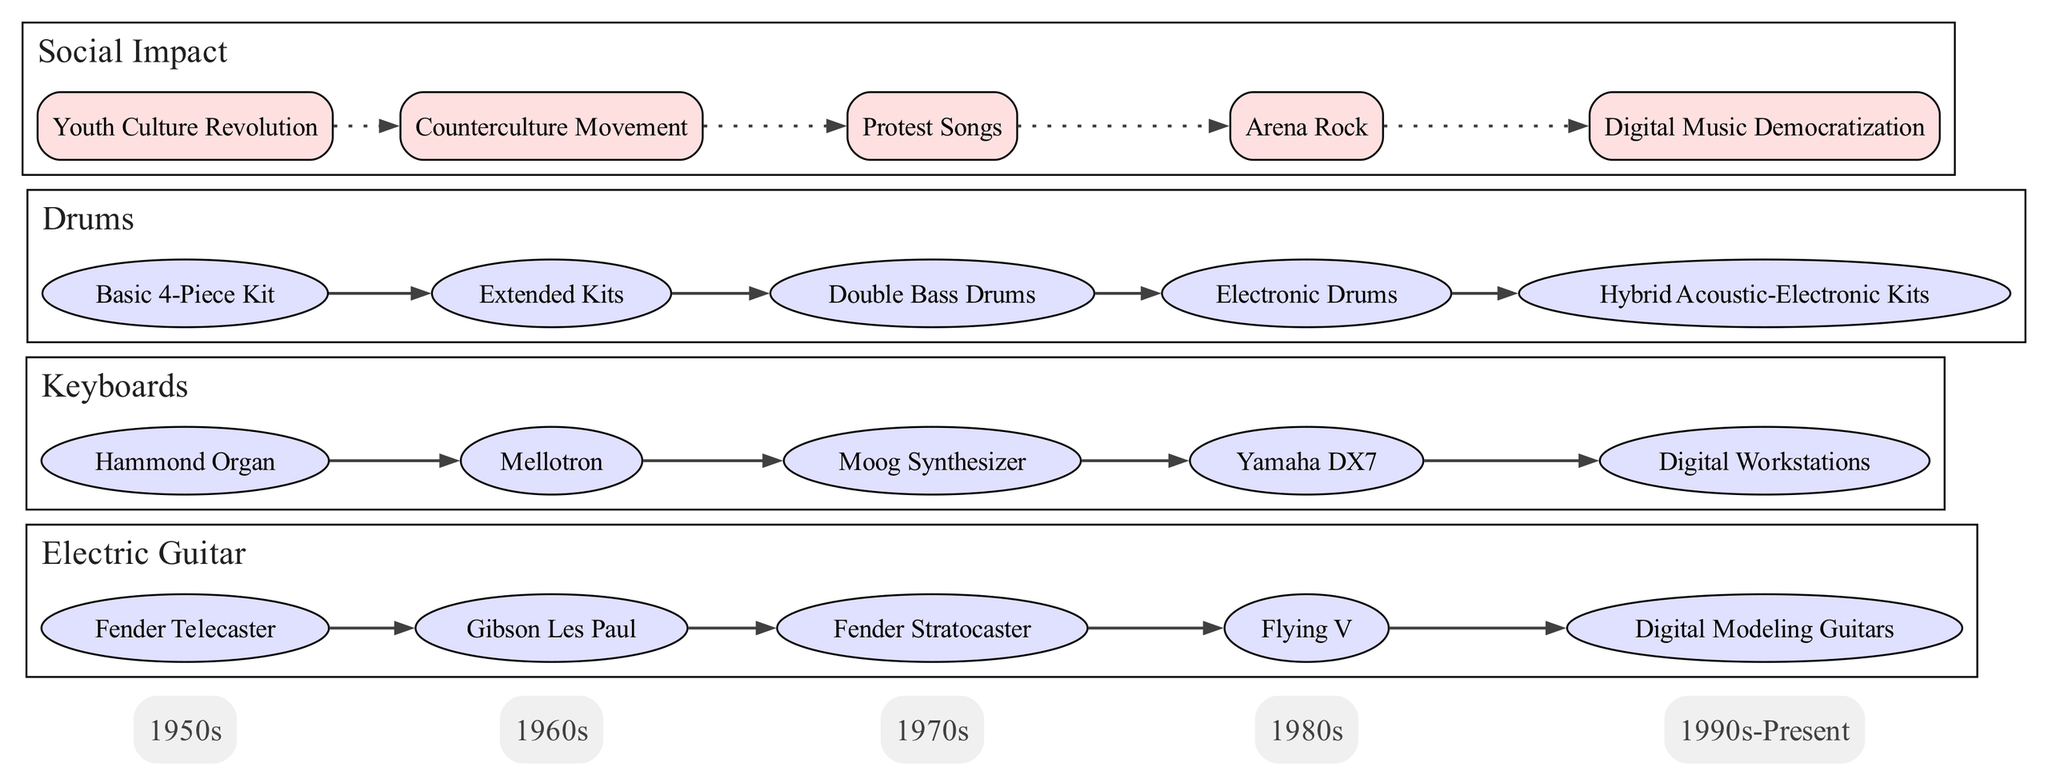What instrument evolved into the Moog Synthesizer? From the diagram, the evolution of Keyboards includes Hammond Organ leading to Mellotron, then to Moog Synthesizer. Therefore, the immediate predecessor to the Moog Synthesizer is the Mellotron.
Answer: Mellotron How many instruments are shown in the diagram? The diagram features three main instruments: Electric Guitar, Keyboards, and Drums. Counting these gives a total of three instruments displayed.
Answer: Three What instrument type was developed in the 1980s? The diagram lists specific instruments under key decades. For the 1980s, the Digital Modeling Guitars for Electric Guitars, Yamaha DX7 for Keyboards, and Electronic Drums for Drums are present. Therefore, Digital Modeling Guitars is an example of an instrument developed in the 1980s.
Answer: Digital Modeling Guitars Which decade introduced Extended Kits for Drums? By examining the timeline and the specific evolution listed for Drums, Extended Kits are indicated as an evolution in the 1970s, placing its introduction in that decade.
Answer: 1970s What is the last evolution listed for Keyboards? The diagram specifically outlines the evolution of Keyboards, where Digital Workstations is indicated as the final entry in the evolution list. Hence, it is the last evolution listed for Keyboards.
Answer: Digital Workstations Which decade correlates with the Counterculture Movement? The social impact section of the diagram mentions various cultural movements. The Counterculture Movement is linked specifically with the 1960s according to this timeline and context.
Answer: 1960s What is the relationship between Digital Music Democratization and the evolution of instruments? Digital Music Democratization appears as a social impact occurring in the 1990s-Present section, reflecting the influence of digital advancements on the evolution of all instruments, as it allows more musicians access to technology. Digital advancements gave rise to many of the later instrument developments noted in the timeline.
Answer: Influence of digital advancements How many social impact elements are listed in the diagram? The social impact section of the diagram provides a list of five distinct elements, which can be directly counted. Therefore, the number of social impacts presented totals five.
Answer: Five What type of instruments are connected to the Flying V? In the diagram, the Flying V is a specific model under the Electric Guitar evolution. It indicates that the Flying V is categorized as an electric guitar model, linking it directly with the Electric Guitar section.
Answer: Electric Guitar 